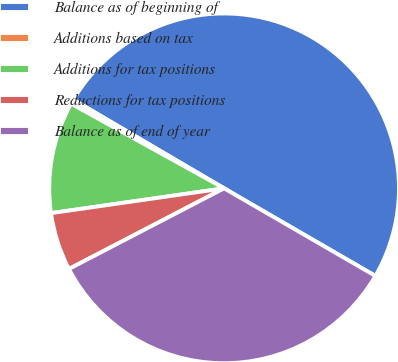Convert chart to OTSL. <chart><loc_0><loc_0><loc_500><loc_500><pie_chart><fcel>Balance as of beginning of<fcel>Additions based on tax<fcel>Additions for tax positions<fcel>Reductions for tax positions<fcel>Balance as of end of year<nl><fcel>49.9%<fcel>0.41%<fcel>10.31%<fcel>5.36%<fcel>34.02%<nl></chart> 